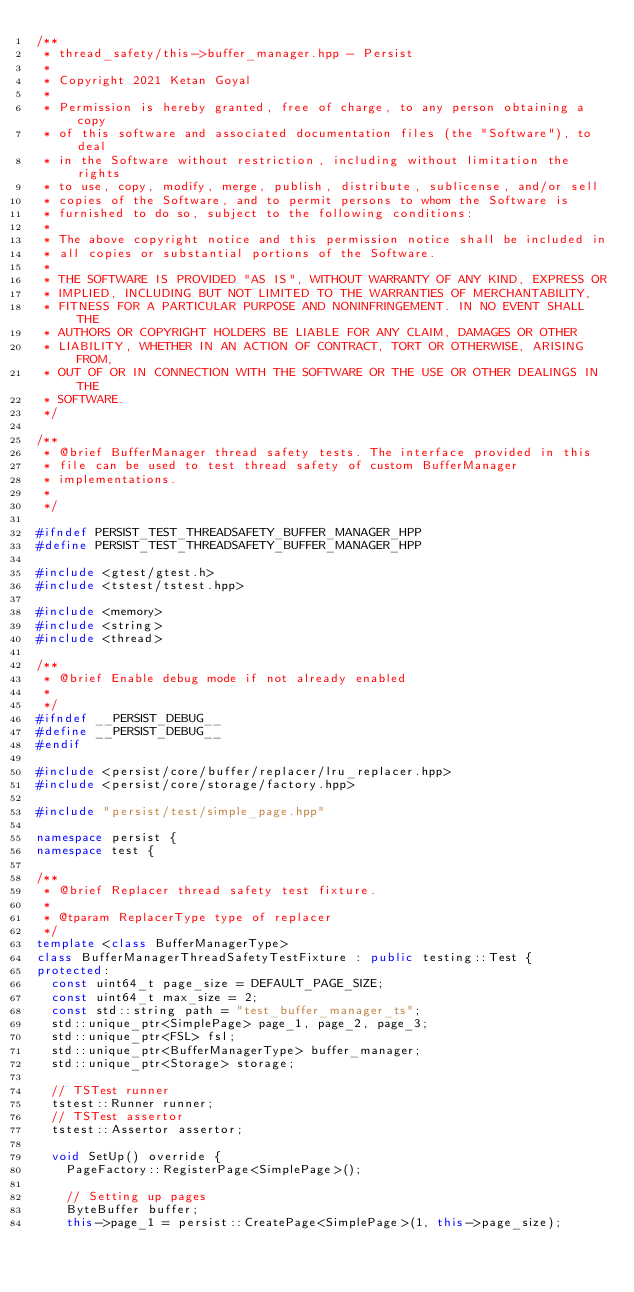Convert code to text. <code><loc_0><loc_0><loc_500><loc_500><_C++_>/**
 * thread_safety/this->buffer_manager.hpp - Persist
 *
 * Copyright 2021 Ketan Goyal
 *
 * Permission is hereby granted, free of charge, to any person obtaining a copy
 * of this software and associated documentation files (the "Software"), to deal
 * in the Software without restriction, including without limitation the rights
 * to use, copy, modify, merge, publish, distribute, sublicense, and/or sell
 * copies of the Software, and to permit persons to whom the Software is
 * furnished to do so, subject to the following conditions:
 *
 * The above copyright notice and this permission notice shall be included in
 * all copies or substantial portions of the Software.
 *
 * THE SOFTWARE IS PROVIDED "AS IS", WITHOUT WARRANTY OF ANY KIND, EXPRESS OR
 * IMPLIED, INCLUDING BUT NOT LIMITED TO THE WARRANTIES OF MERCHANTABILITY,
 * FITNESS FOR A PARTICULAR PURPOSE AND NONINFRINGEMENT. IN NO EVENT SHALL THE
 * AUTHORS OR COPYRIGHT HOLDERS BE LIABLE FOR ANY CLAIM, DAMAGES OR OTHER
 * LIABILITY, WHETHER IN AN ACTION OF CONTRACT, TORT OR OTHERWISE, ARISING FROM,
 * OUT OF OR IN CONNECTION WITH THE SOFTWARE OR THE USE OR OTHER DEALINGS IN THE
 * SOFTWARE.
 */

/**
 * @brief BufferManager thread safety tests. The interface provided in this
 * file can be used to test thread safety of custom BufferManager
 * implementations.
 *
 */

#ifndef PERSIST_TEST_THREADSAFETY_BUFFER_MANAGER_HPP
#define PERSIST_TEST_THREADSAFETY_BUFFER_MANAGER_HPP

#include <gtest/gtest.h>
#include <tstest/tstest.hpp>

#include <memory>
#include <string>
#include <thread>

/**
 * @brief Enable debug mode if not already enabled
 *
 */
#ifndef __PERSIST_DEBUG__
#define __PERSIST_DEBUG__
#endif

#include <persist/core/buffer/replacer/lru_replacer.hpp>
#include <persist/core/storage/factory.hpp>

#include "persist/test/simple_page.hpp"

namespace persist {
namespace test {

/**
 * @brief Replacer thread safety test fixture.
 *
 * @tparam ReplacerType type of replacer
 */
template <class BufferManagerType>
class BufferManagerThreadSafetyTestFixture : public testing::Test {
protected:
  const uint64_t page_size = DEFAULT_PAGE_SIZE;
  const uint64_t max_size = 2;
  const std::string path = "test_buffer_manager_ts";
  std::unique_ptr<SimplePage> page_1, page_2, page_3;
  std::unique_ptr<FSL> fsl;
  std::unique_ptr<BufferManagerType> buffer_manager;
  std::unique_ptr<Storage> storage;

  // TSTest runner
  tstest::Runner runner;
  // TSTest assertor
  tstest::Assertor assertor;

  void SetUp() override {
    PageFactory::RegisterPage<SimplePage>();

    // Setting up pages
    ByteBuffer buffer;
    this->page_1 = persist::CreatePage<SimplePage>(1, this->page_size);</code> 